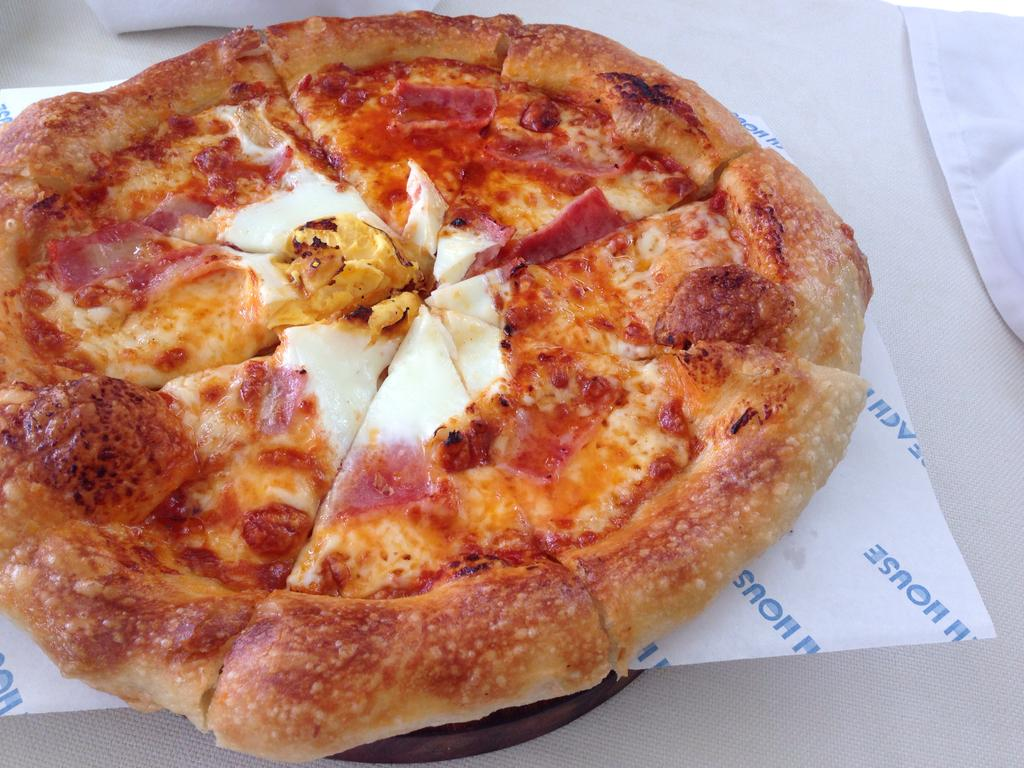What type of food is shown in the image? There are slices of pizza in the image. How are the pizza slices arranged or presented? The pizza slices are on tissue paper. Can you describe any other visible materials in the image? There is a part of a cloth visible in the image. What type of rock can be seen in the image? There is no rock present in the image; it features slices of pizza on tissue paper and a part of a cloth. 